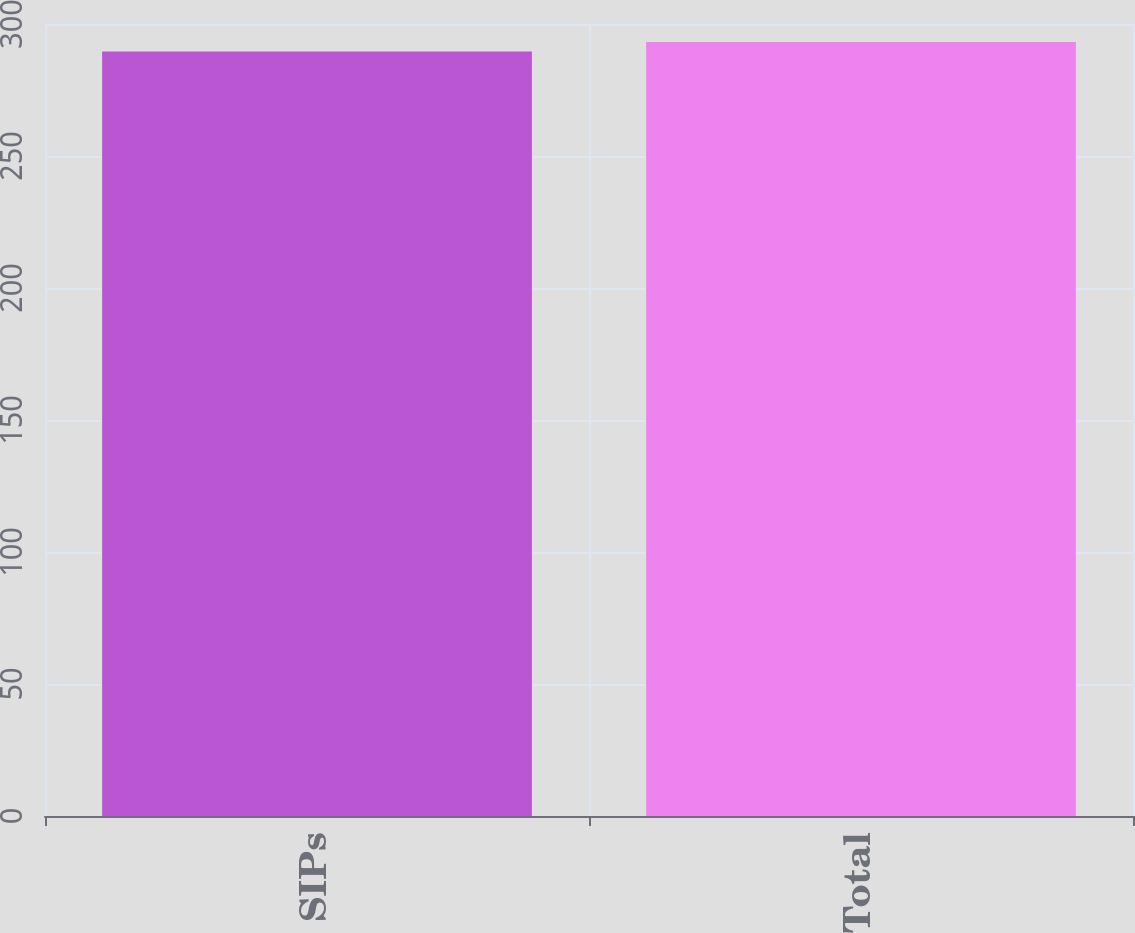<chart> <loc_0><loc_0><loc_500><loc_500><bar_chart><fcel>SIPs<fcel>Total<nl><fcel>289.6<fcel>293.2<nl></chart> 